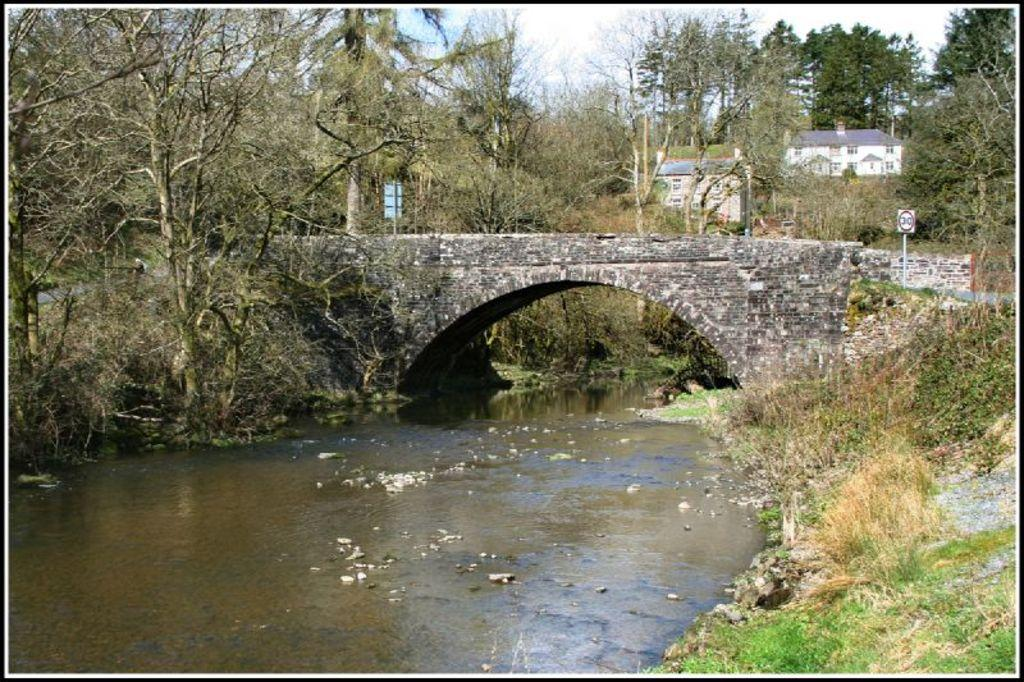What is the primary element visible in the image? There is water in the image. What type of terrain is present in the image? There is grass on the ground in the image. What other natural elements can be seen in the image? There are trees in the image. What man-made structure is present in the image? There is a bridge in the image. What can be seen in the background of the image? There are trees, buildings, and two boards in the background of the image. What part of the natural environment is visible in the background of the image? The sky is visible in the background of the image. How many facts can be adjusted in the image? The term "adjust" is not applicable to the image, as it refers to modifying or changing something. The image is a static representation of the facts provided. 